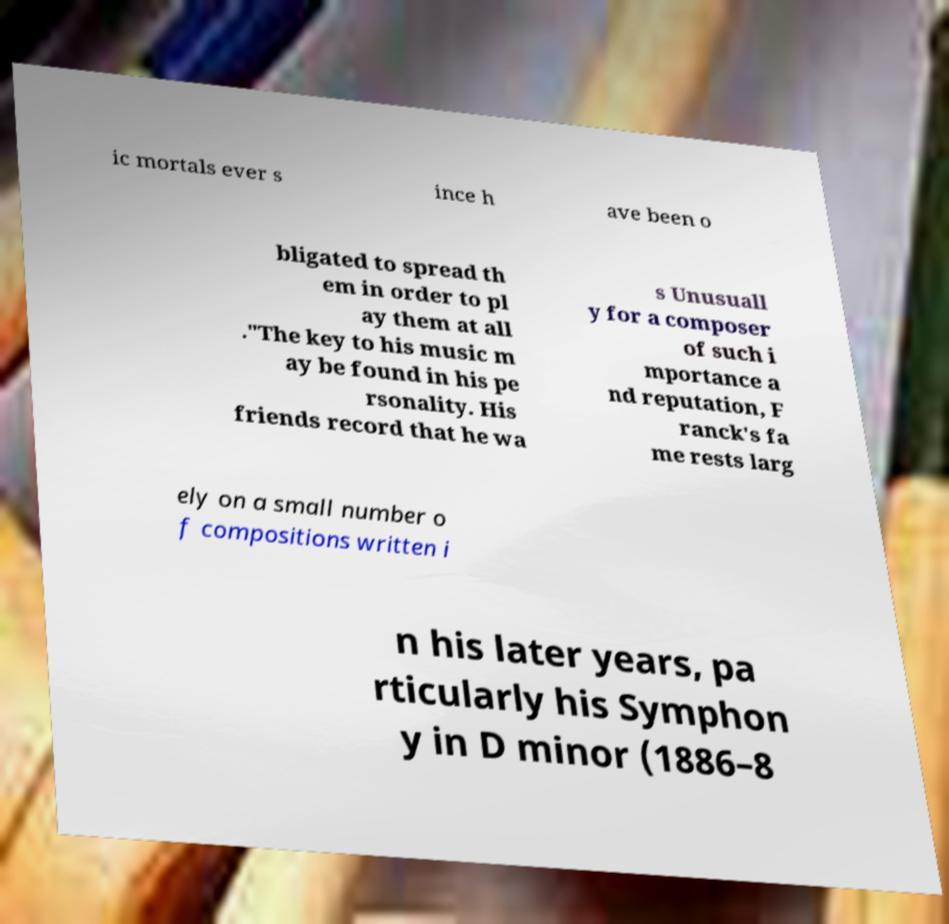Can you read and provide the text displayed in the image?This photo seems to have some interesting text. Can you extract and type it out for me? ic mortals ever s ince h ave been o bligated to spread th em in order to pl ay them at all ."The key to his music m ay be found in his pe rsonality. His friends record that he wa s Unusuall y for a composer of such i mportance a nd reputation, F ranck's fa me rests larg ely on a small number o f compositions written i n his later years, pa rticularly his Symphon y in D minor (1886–8 